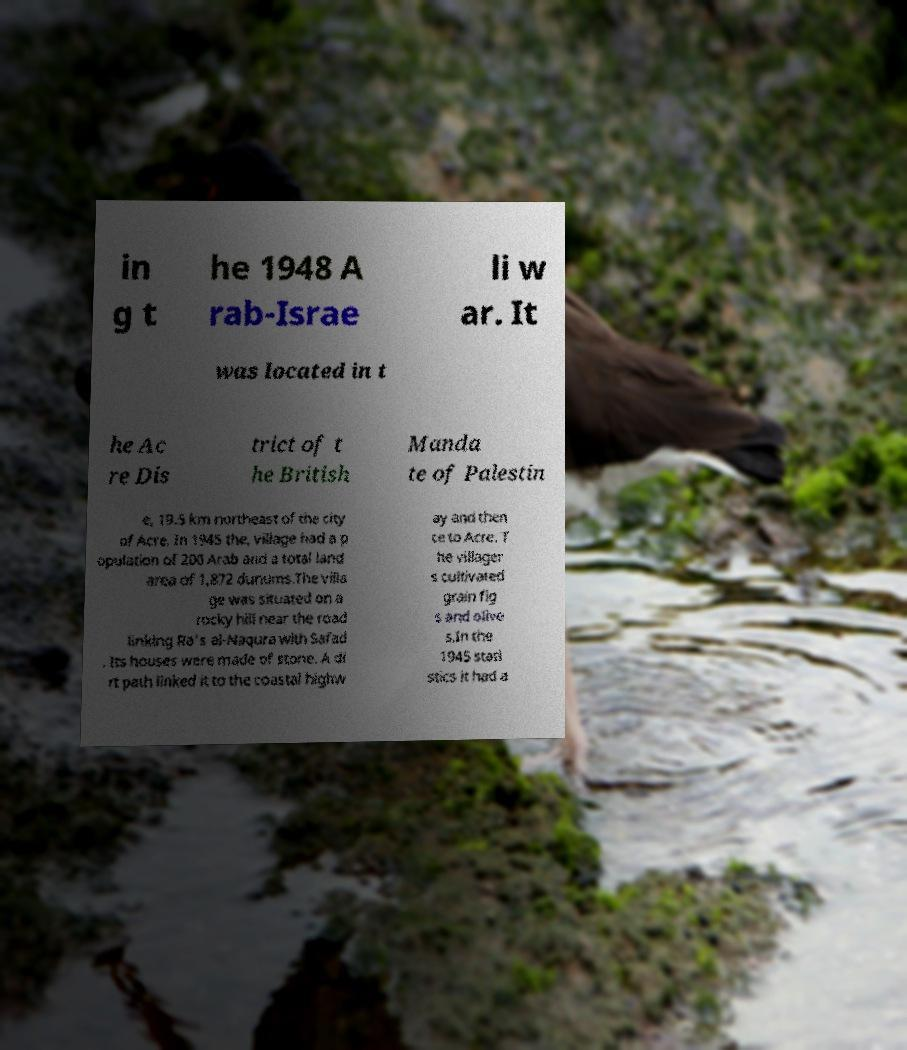Please identify and transcribe the text found in this image. in g t he 1948 A rab-Israe li w ar. It was located in t he Ac re Dis trict of t he British Manda te of Palestin e, 19.5 km northeast of the city of Acre. In 1945 the, village had a p opulation of 200 Arab and a total land area of 1,872 dunums.The villa ge was situated on a rocky hill near the road linking Ra's al-Naqura with Safad . Its houses were made of stone. A di rt path linked it to the coastal highw ay and then ce to Acre. T he villager s cultivated grain fig s and olive s.In the 1945 stati stics it had a 